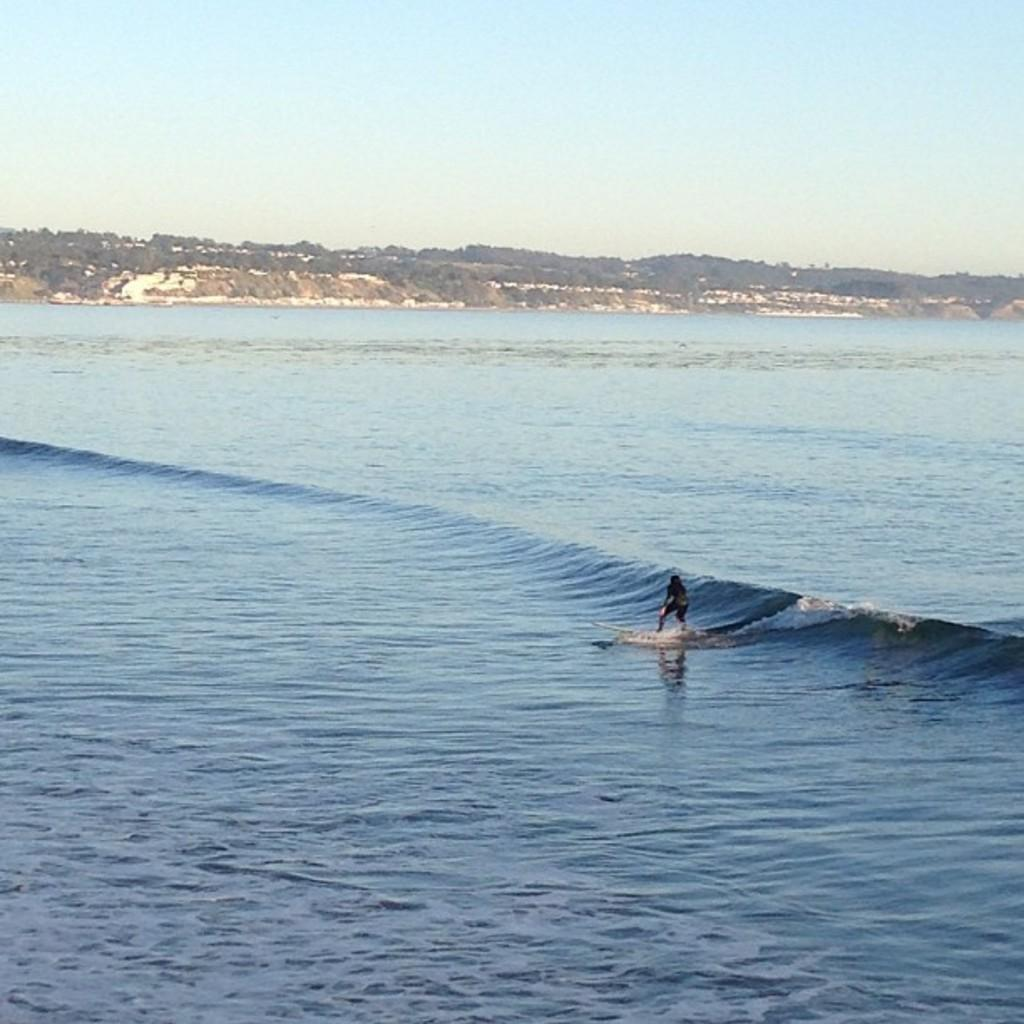What is the main activity taking place in the foreground of the image? There is a person surfing in the foreground of the image. What is the primary element in the foreground? There is water in the foreground of the image. What can be seen in the background of the image? Trees and the sky are visible in the background of the image. What type of selection is being made by the airplane in the image? There is no airplane present in the image, so no selection is being made by an airplane. 